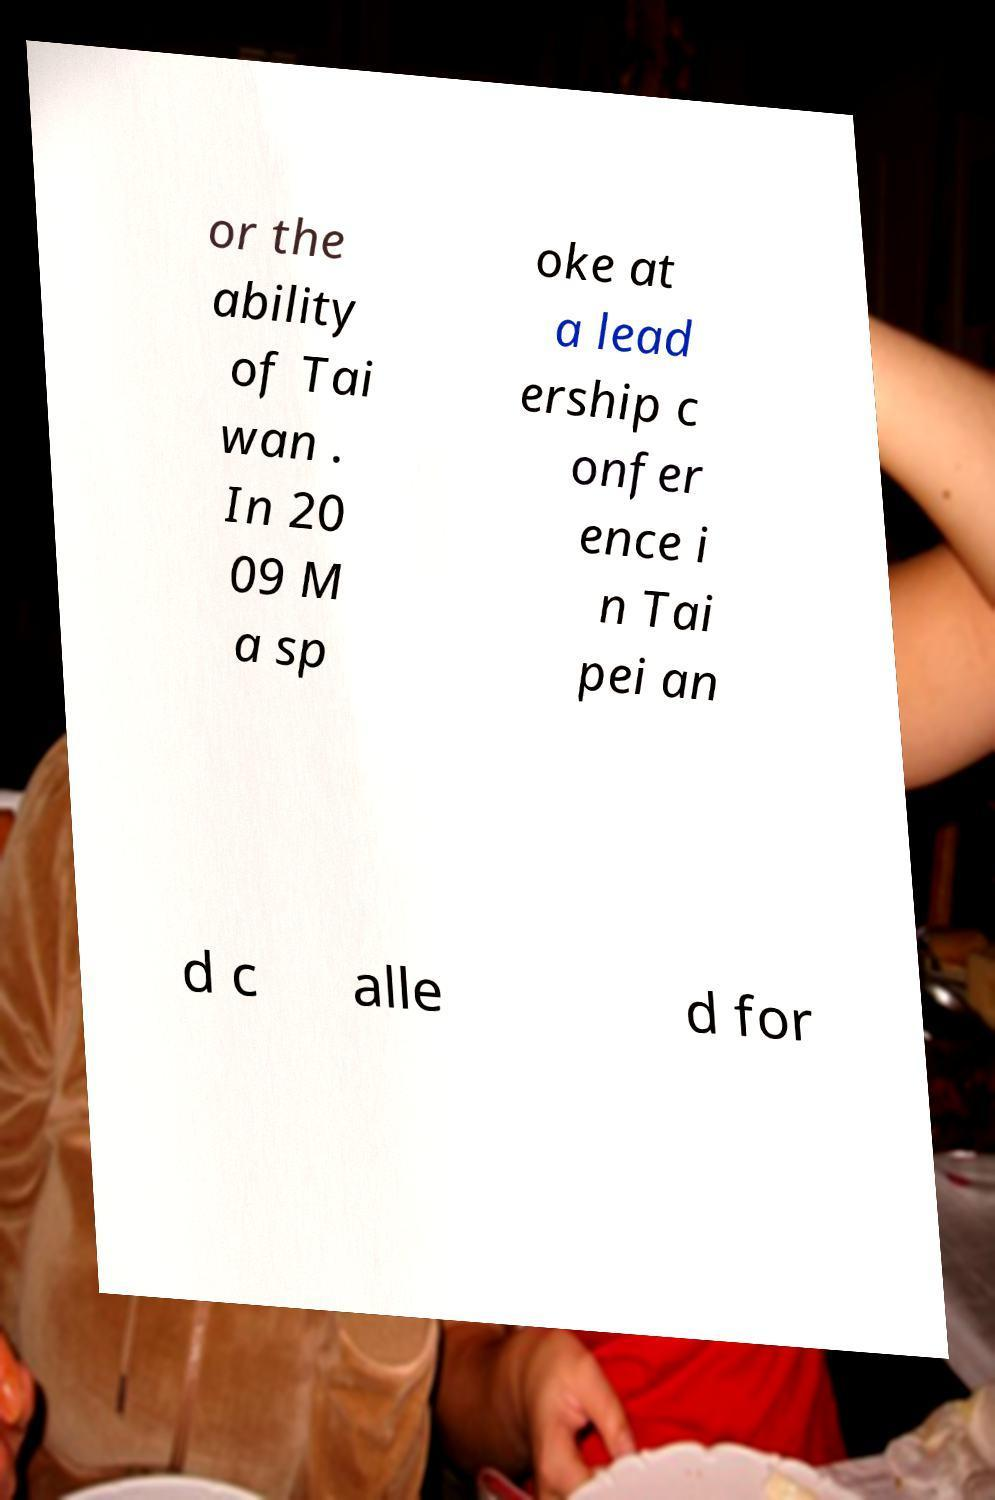There's text embedded in this image that I need extracted. Can you transcribe it verbatim? or the ability of Tai wan . In 20 09 M a sp oke at a lead ership c onfer ence i n Tai pei an d c alle d for 